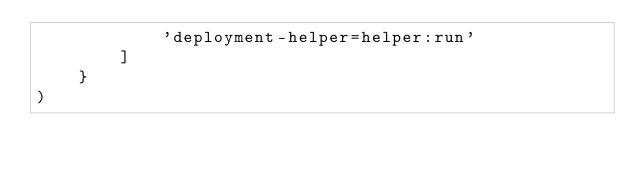Convert code to text. <code><loc_0><loc_0><loc_500><loc_500><_Python_>            'deployment-helper=helper:run'
        ]
    }
)
</code> 